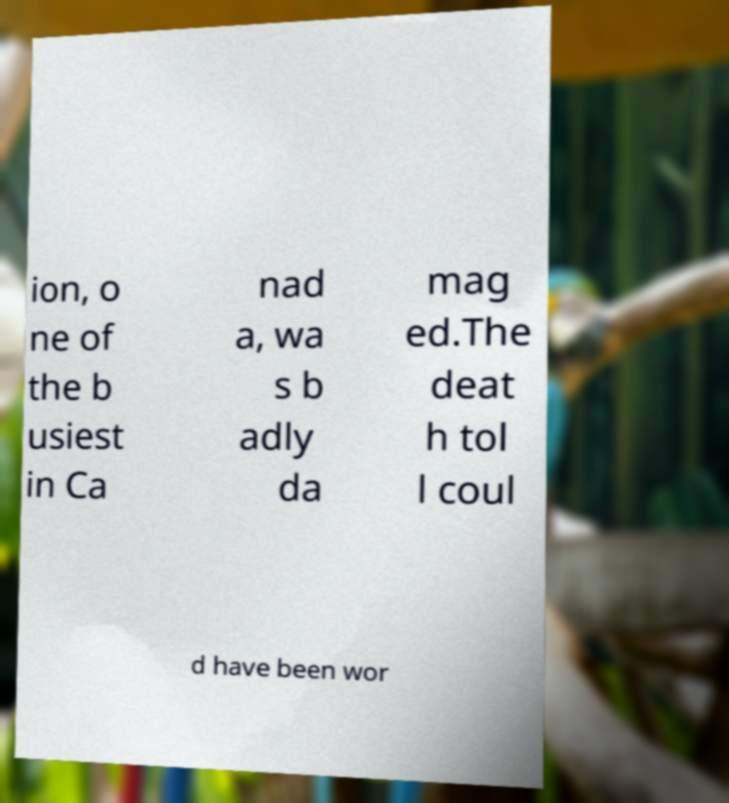I need the written content from this picture converted into text. Can you do that? ion, o ne of the b usiest in Ca nad a, wa s b adly da mag ed.The deat h tol l coul d have been wor 